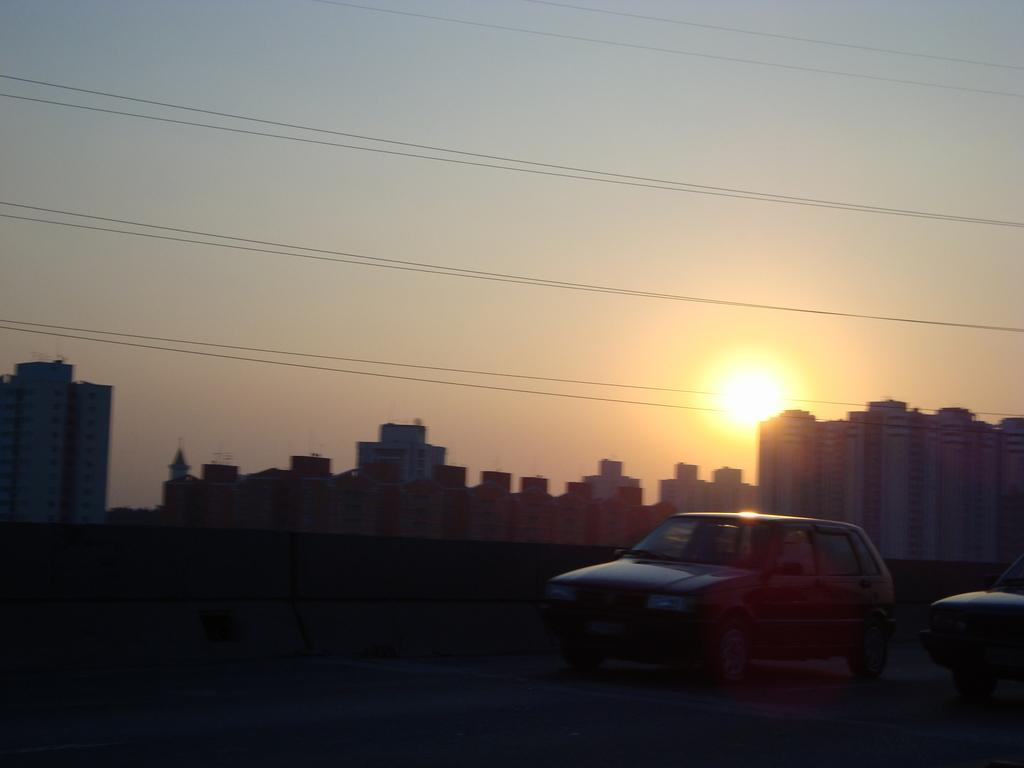What can be seen in the center of the image? There are two vehicles in the center of the image. What is visible in the background of the image? The sky, the sun, buildings, wires, and a wall are visible in the background of the image. Can you tell me how many shops are visible in the image? There is no shop present in the image. How does the airplane stretch its wings in the image? There is no airplane present in the image, so it cannot stretch its wings. 